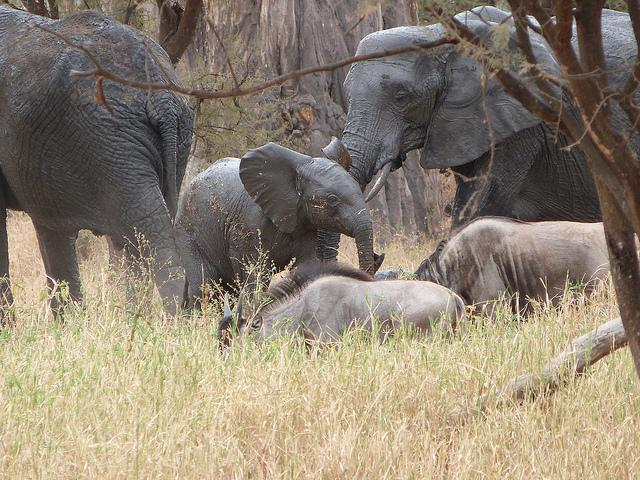What feature do these animals have?

Choices:
A) talons
B) wings
C) quills
D) trunks trunks 